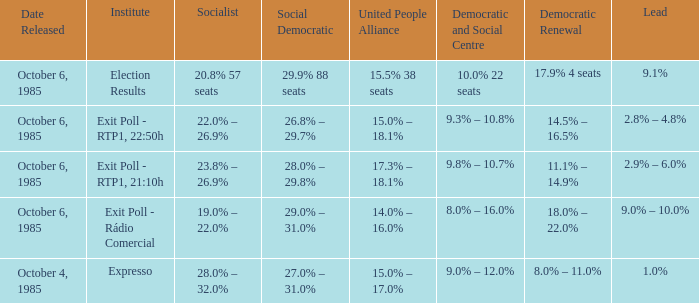0% in a polling from october 6, 1985? Exit Poll - Rádio Comercial. 